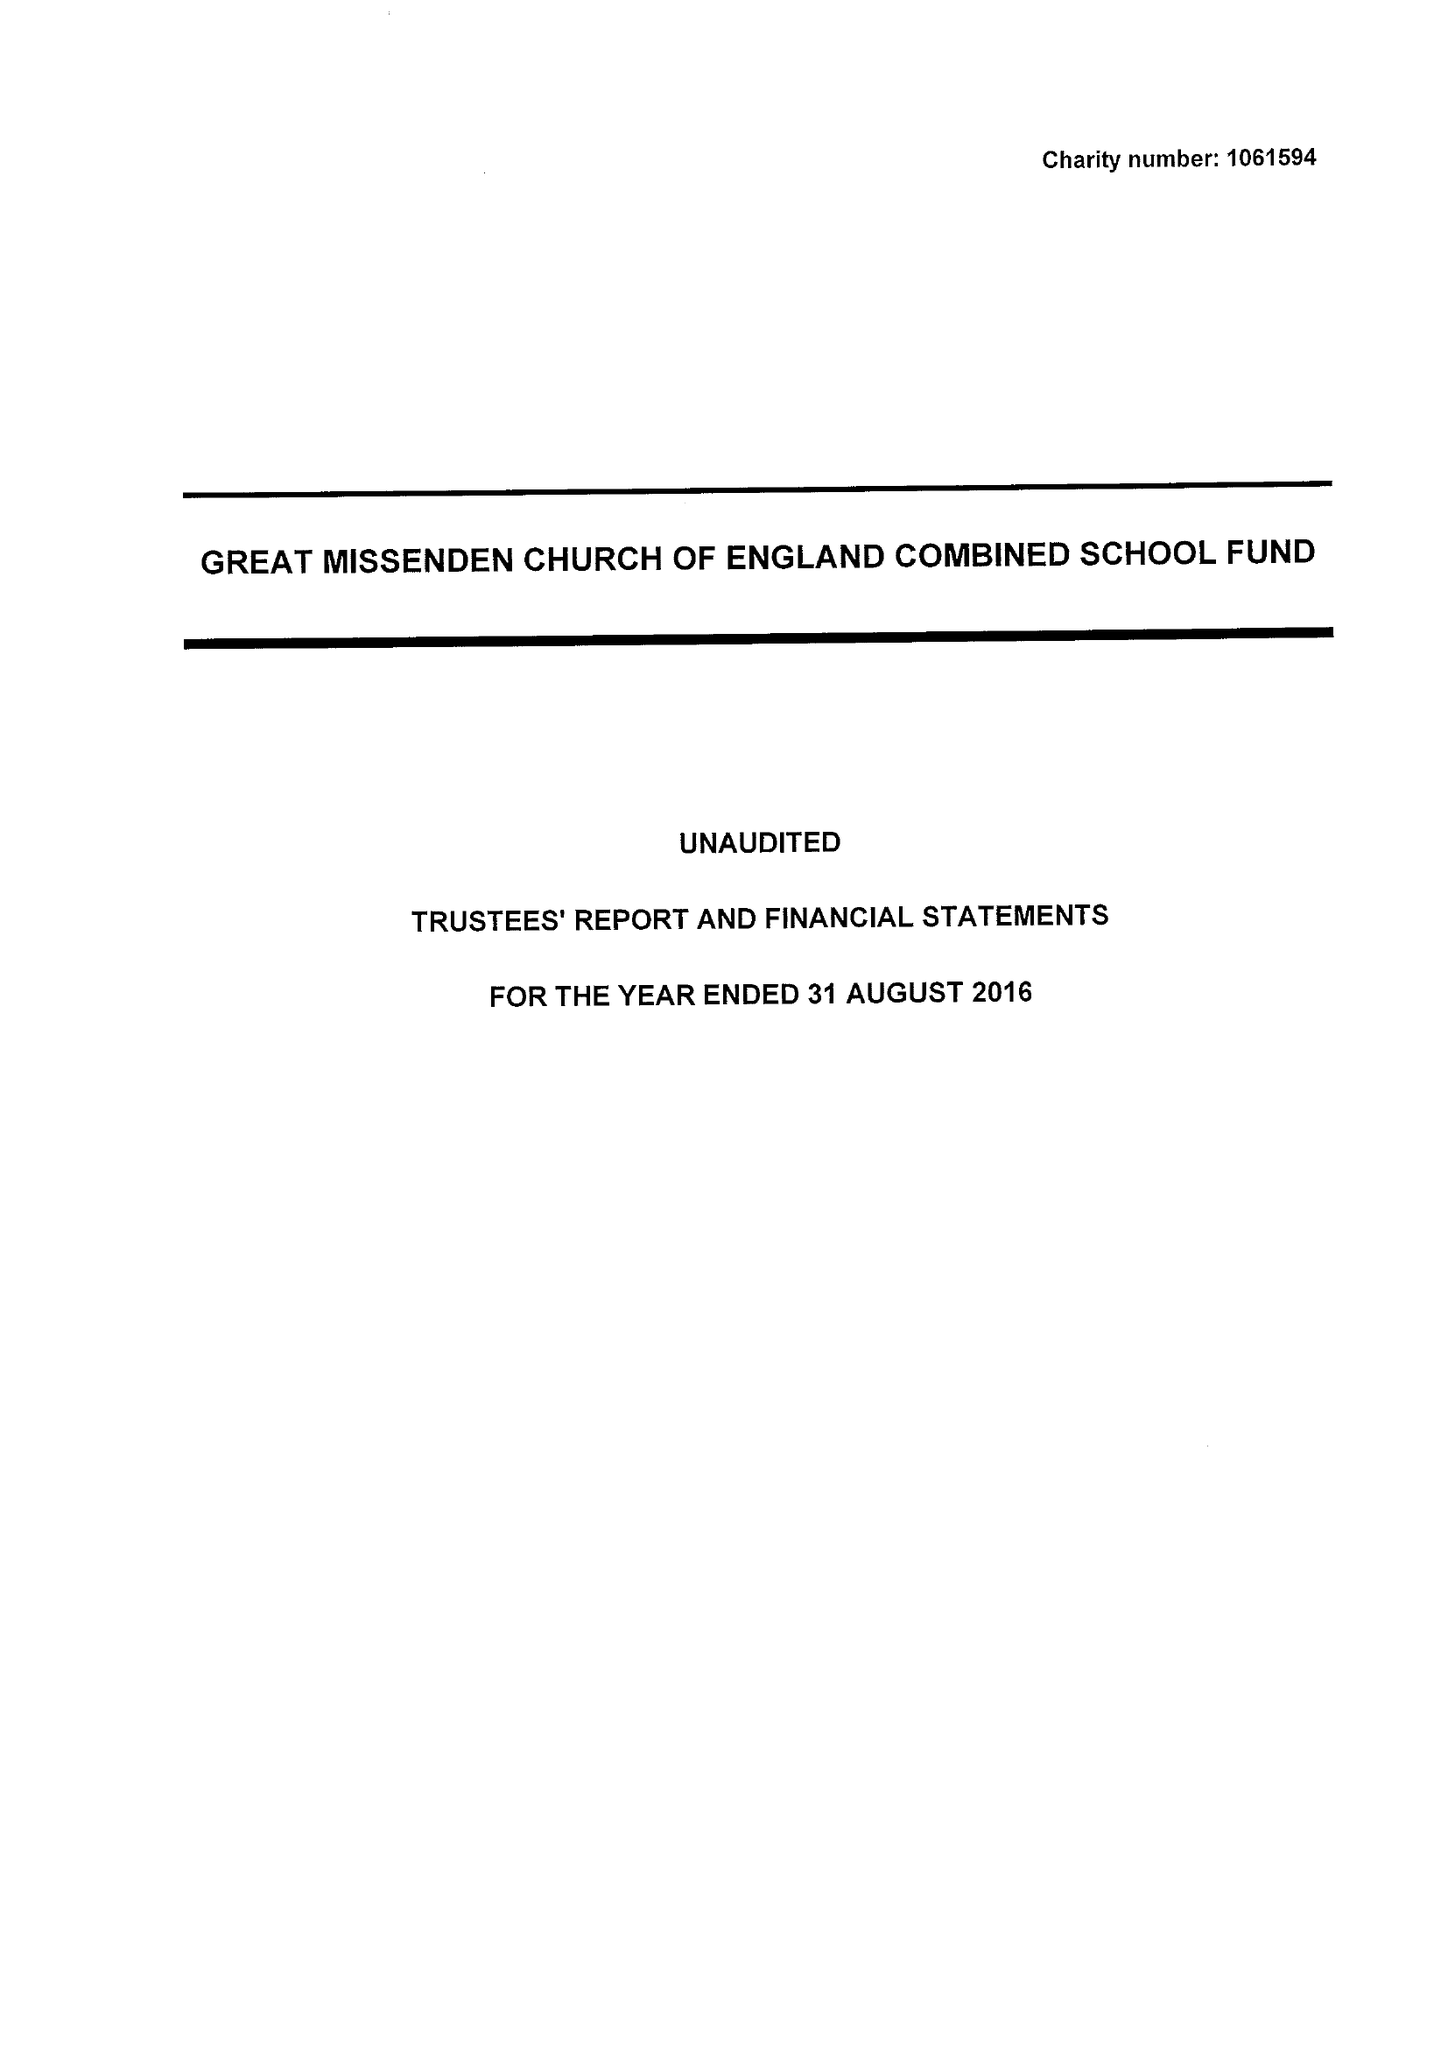What is the value for the report_date?
Answer the question using a single word or phrase. 2016-08-31 